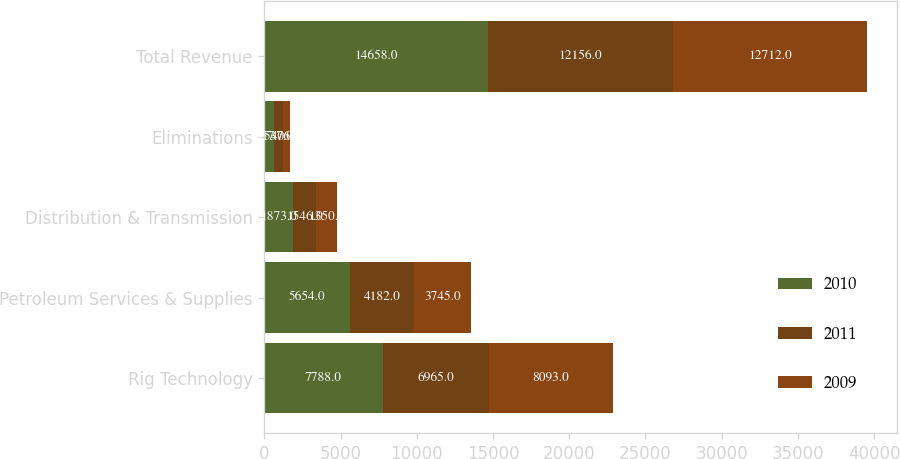<chart> <loc_0><loc_0><loc_500><loc_500><stacked_bar_chart><ecel><fcel>Rig Technology<fcel>Petroleum Services & Supplies<fcel>Distribution & Transmission<fcel>Eliminations<fcel>Total Revenue<nl><fcel>2010<fcel>7788<fcel>5654<fcel>1873<fcel>657<fcel>14658<nl><fcel>2011<fcel>6965<fcel>4182<fcel>1546<fcel>537<fcel>12156<nl><fcel>2009<fcel>8093<fcel>3745<fcel>1350<fcel>476<fcel>12712<nl></chart> 